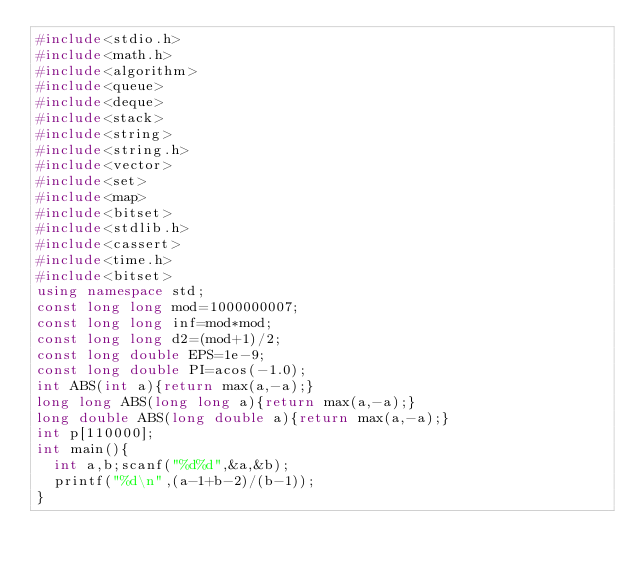<code> <loc_0><loc_0><loc_500><loc_500><_C++_>#include<stdio.h>
#include<math.h>
#include<algorithm>
#include<queue>
#include<deque>
#include<stack>
#include<string>
#include<string.h>
#include<vector>
#include<set>
#include<map>
#include<bitset>
#include<stdlib.h>
#include<cassert>
#include<time.h>
#include<bitset>
using namespace std;
const long long mod=1000000007;
const long long inf=mod*mod;
const long long d2=(mod+1)/2;
const long double EPS=1e-9;
const long double PI=acos(-1.0);
int ABS(int a){return max(a,-a);}
long long ABS(long long a){return max(a,-a);}
long double ABS(long double a){return max(a,-a);}
int p[110000];
int main(){
	int a,b;scanf("%d%d",&a,&b);
	printf("%d\n",(a-1+b-2)/(b-1));
}</code> 